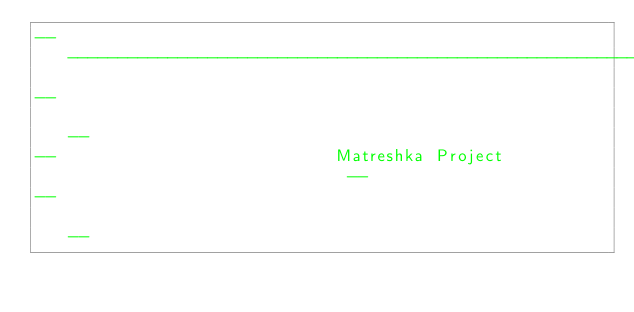Convert code to text. <code><loc_0><loc_0><loc_500><loc_500><_Ada_>------------------------------------------------------------------------------
--                                                                          --
--                            Matreshka Project                             --
--                                                                          --</code> 